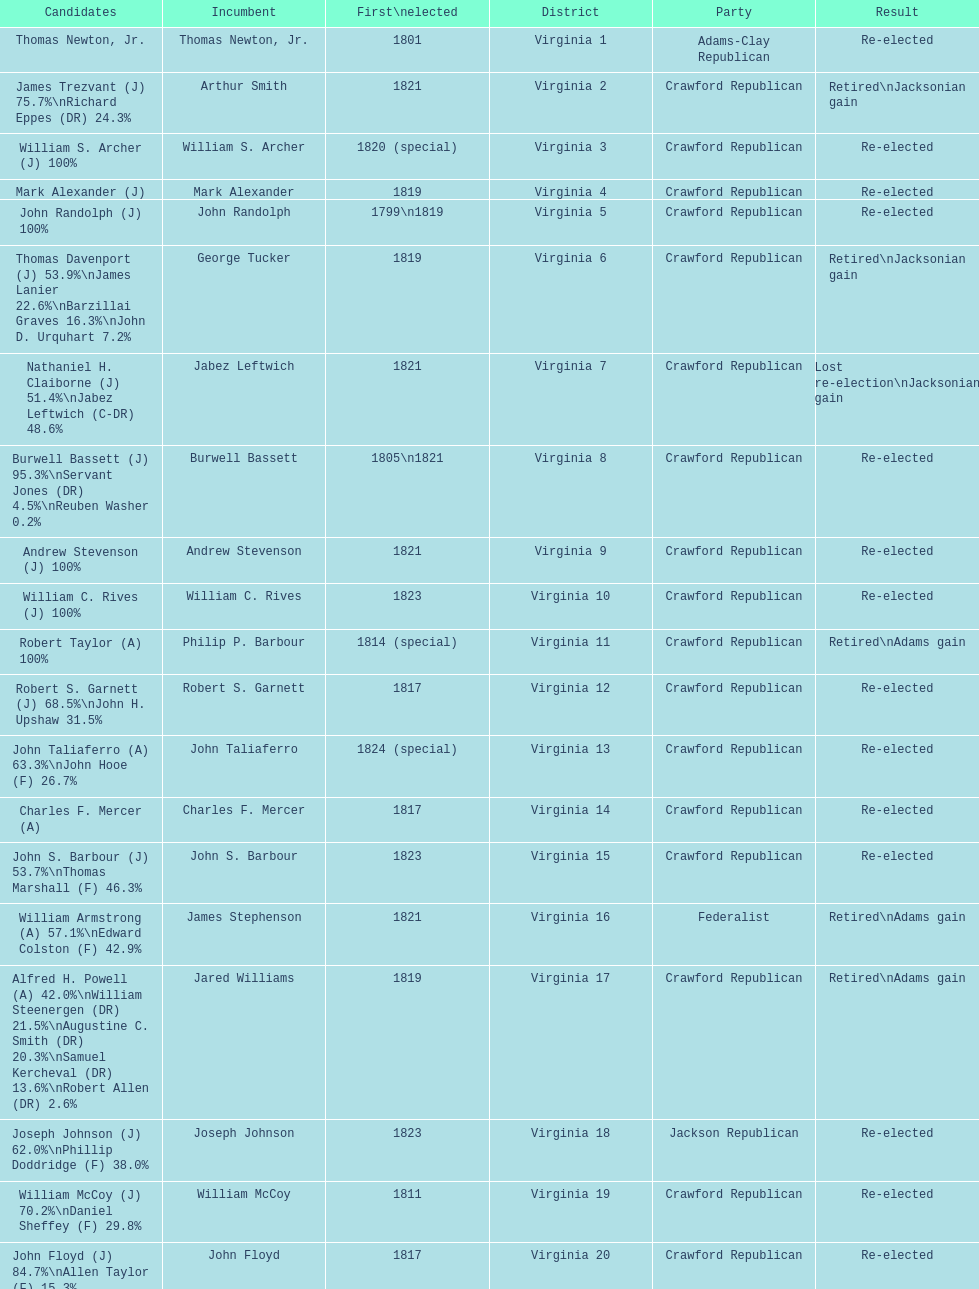Number of incumbents who retired or lost re-election 7. 